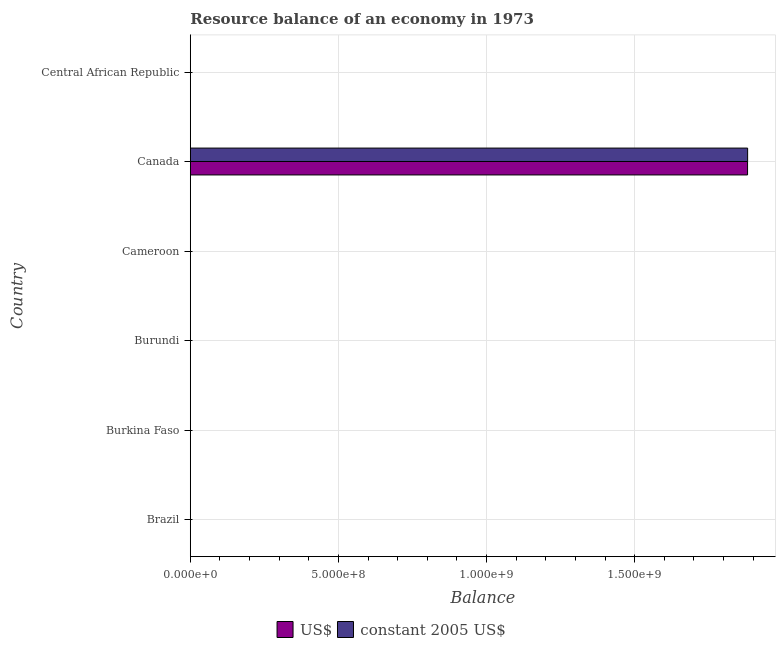How many different coloured bars are there?
Your response must be concise. 2. Across all countries, what is the maximum resource balance in constant us$?
Keep it short and to the point. 1.88e+09. In which country was the resource balance in us$ maximum?
Your answer should be very brief. Canada. What is the total resource balance in constant us$ in the graph?
Keep it short and to the point. 1.88e+09. What is the difference between the resource balance in us$ in Burundi and the resource balance in constant us$ in Canada?
Your answer should be compact. -1.88e+09. What is the average resource balance in constant us$ per country?
Make the answer very short. 3.14e+08. What is the difference between the resource balance in us$ and resource balance in constant us$ in Canada?
Keep it short and to the point. -1.88e+05. What is the difference between the highest and the lowest resource balance in constant us$?
Make the answer very short. 1.88e+09. What is the difference between two consecutive major ticks on the X-axis?
Give a very brief answer. 5.00e+08. Are the values on the major ticks of X-axis written in scientific E-notation?
Your answer should be very brief. Yes. How many legend labels are there?
Your answer should be compact. 2. How are the legend labels stacked?
Provide a succinct answer. Horizontal. What is the title of the graph?
Provide a short and direct response. Resource balance of an economy in 1973. Does "Urban" appear as one of the legend labels in the graph?
Ensure brevity in your answer.  No. What is the label or title of the X-axis?
Offer a terse response. Balance. What is the label or title of the Y-axis?
Your answer should be very brief. Country. What is the Balance of constant 2005 US$ in Burkina Faso?
Your answer should be very brief. 0. What is the Balance in US$ in Burundi?
Provide a succinct answer. 0. What is the Balance of constant 2005 US$ in Burundi?
Make the answer very short. 0. What is the Balance of US$ in Cameroon?
Ensure brevity in your answer.  0. What is the Balance of constant 2005 US$ in Cameroon?
Provide a succinct answer. 0. What is the Balance of US$ in Canada?
Make the answer very short. 1.88e+09. What is the Balance in constant 2005 US$ in Canada?
Make the answer very short. 1.88e+09. What is the Balance of US$ in Central African Republic?
Provide a succinct answer. 0. What is the Balance of constant 2005 US$ in Central African Republic?
Provide a succinct answer. 0. Across all countries, what is the maximum Balance in US$?
Keep it short and to the point. 1.88e+09. Across all countries, what is the maximum Balance of constant 2005 US$?
Keep it short and to the point. 1.88e+09. What is the total Balance of US$ in the graph?
Your answer should be very brief. 1.88e+09. What is the total Balance in constant 2005 US$ in the graph?
Give a very brief answer. 1.88e+09. What is the average Balance in US$ per country?
Offer a terse response. 3.13e+08. What is the average Balance in constant 2005 US$ per country?
Make the answer very short. 3.14e+08. What is the difference between the Balance in US$ and Balance in constant 2005 US$ in Canada?
Your response must be concise. -1.88e+05. What is the difference between the highest and the lowest Balance of US$?
Provide a succinct answer. 1.88e+09. What is the difference between the highest and the lowest Balance of constant 2005 US$?
Give a very brief answer. 1.88e+09. 